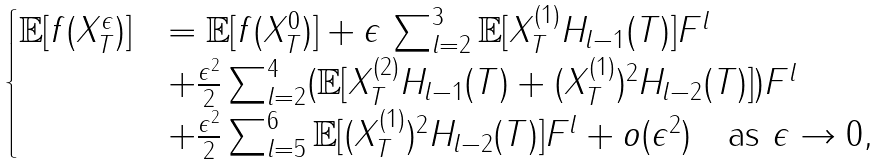Convert formula to latex. <formula><loc_0><loc_0><loc_500><loc_500>\begin{cases} \mathbb { E } [ f ( X _ { T } ^ { \epsilon } ) ] & = \mathbb { E } [ f ( X _ { T } ^ { 0 } ) ] + \epsilon \, \sum _ { l = 2 } ^ { 3 } \mathbb { E } [ X _ { T } ^ { ( 1 ) } H _ { l - 1 } ( T ) ] F ^ { l } \\ & + \frac { \epsilon ^ { 2 } } { 2 } \sum _ { l = 2 } ^ { 4 } ( \mathbb { E } [ X _ { T } ^ { ( 2 ) } H _ { l - 1 } ( T ) + ( X _ { T } ^ { ( 1 ) } ) ^ { 2 } H _ { l - 2 } ( T ) ] ) F ^ { l } \\ & + \frac { \epsilon ^ { 2 } } { 2 } \sum _ { l = 5 } ^ { 6 } \mathbb { E } [ ( X _ { T } ^ { ( 1 ) } ) ^ { 2 } H _ { l - 2 } ( T ) ] F ^ { l } + o ( \epsilon ^ { 2 } ) \quad \text {as } \epsilon \rightarrow 0 , \end{cases}</formula> 